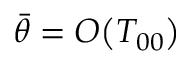<formula> <loc_0><loc_0><loc_500><loc_500>\begin{array} { r } { \bar { \theta } = { O } \, \left ( T _ { 0 0 } \right ) } \end{array}</formula> 